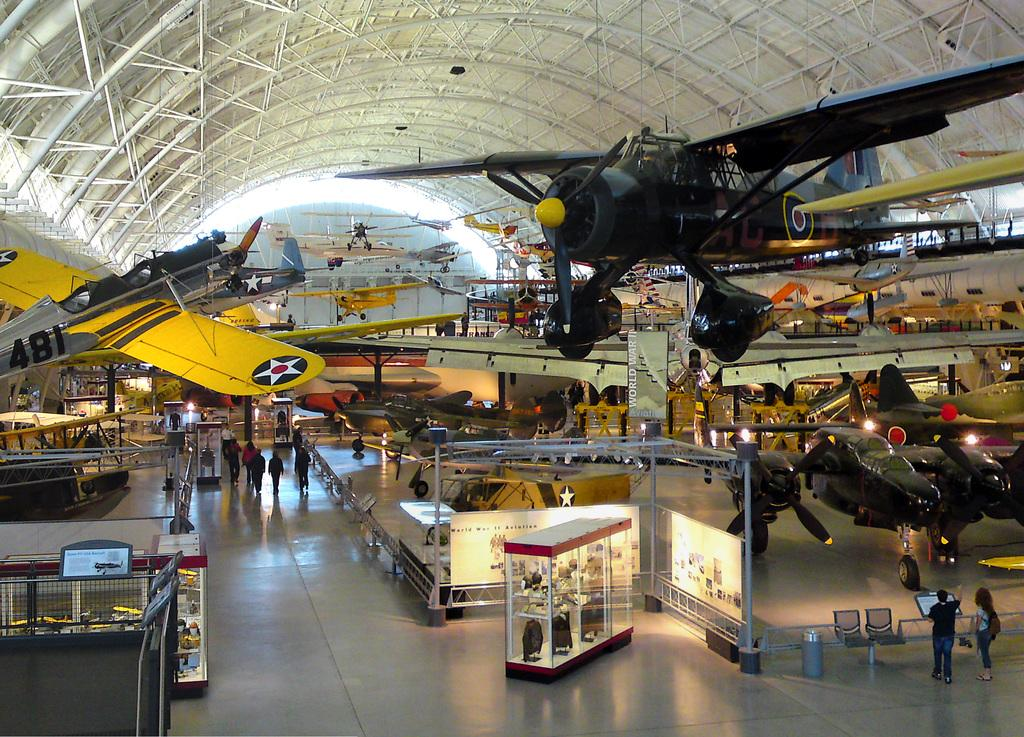<image>
Write a terse but informative summary of the picture. An airplane with number 481 on it hangs from the ceiling of a museum. 